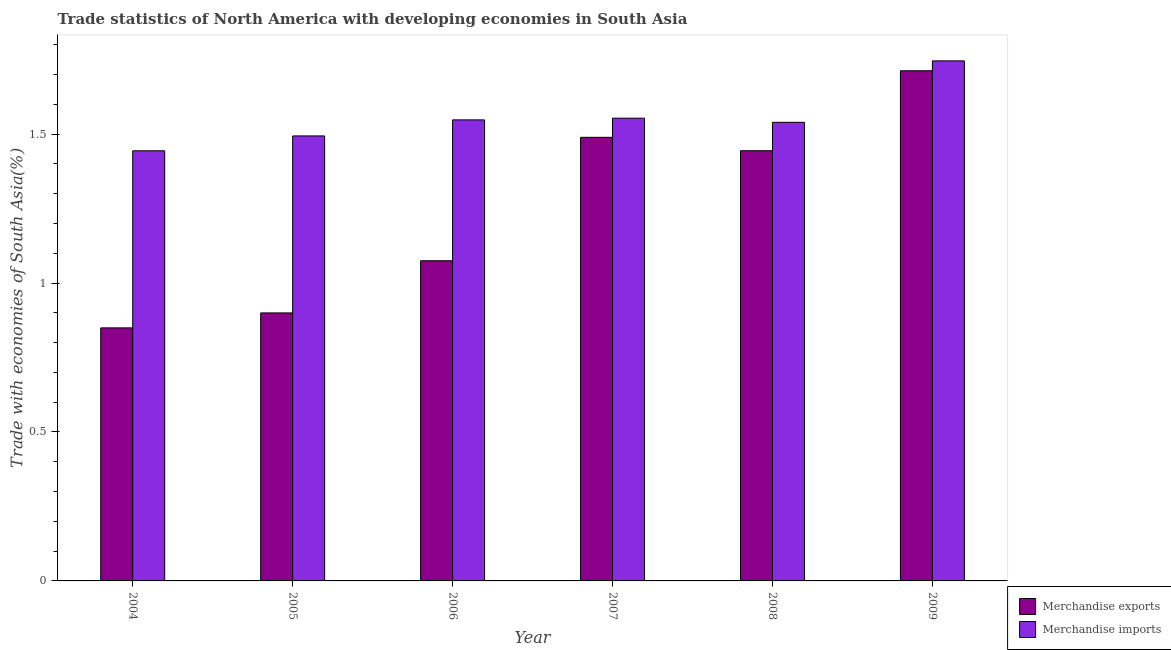How many different coloured bars are there?
Keep it short and to the point. 2. How many groups of bars are there?
Provide a short and direct response. 6. Are the number of bars on each tick of the X-axis equal?
Your response must be concise. Yes. How many bars are there on the 6th tick from the left?
Keep it short and to the point. 2. In how many cases, is the number of bars for a given year not equal to the number of legend labels?
Offer a very short reply. 0. What is the merchandise imports in 2004?
Provide a succinct answer. 1.44. Across all years, what is the maximum merchandise imports?
Make the answer very short. 1.75. Across all years, what is the minimum merchandise exports?
Give a very brief answer. 0.85. In which year was the merchandise exports minimum?
Provide a short and direct response. 2004. What is the total merchandise exports in the graph?
Provide a succinct answer. 7.47. What is the difference between the merchandise imports in 2004 and that in 2007?
Ensure brevity in your answer.  -0.11. What is the difference between the merchandise imports in 2008 and the merchandise exports in 2009?
Ensure brevity in your answer.  -0.21. What is the average merchandise exports per year?
Make the answer very short. 1.24. In the year 2009, what is the difference between the merchandise imports and merchandise exports?
Offer a terse response. 0. In how many years, is the merchandise imports greater than 1.2 %?
Provide a short and direct response. 6. What is the ratio of the merchandise imports in 2007 to that in 2009?
Keep it short and to the point. 0.89. Is the merchandise imports in 2005 less than that in 2008?
Keep it short and to the point. Yes. What is the difference between the highest and the second highest merchandise exports?
Make the answer very short. 0.22. What is the difference between the highest and the lowest merchandise imports?
Offer a terse response. 0.3. Is the sum of the merchandise imports in 2007 and 2008 greater than the maximum merchandise exports across all years?
Provide a short and direct response. Yes. How many bars are there?
Your answer should be very brief. 12. How many years are there in the graph?
Make the answer very short. 6. What is the difference between two consecutive major ticks on the Y-axis?
Make the answer very short. 0.5. Are the values on the major ticks of Y-axis written in scientific E-notation?
Your answer should be very brief. No. Does the graph contain grids?
Give a very brief answer. No. How many legend labels are there?
Keep it short and to the point. 2. How are the legend labels stacked?
Offer a terse response. Vertical. What is the title of the graph?
Provide a short and direct response. Trade statistics of North America with developing economies in South Asia. What is the label or title of the Y-axis?
Provide a short and direct response. Trade with economies of South Asia(%). What is the Trade with economies of South Asia(%) in Merchandise exports in 2004?
Provide a succinct answer. 0.85. What is the Trade with economies of South Asia(%) of Merchandise imports in 2004?
Ensure brevity in your answer.  1.44. What is the Trade with economies of South Asia(%) in Merchandise exports in 2005?
Ensure brevity in your answer.  0.9. What is the Trade with economies of South Asia(%) of Merchandise imports in 2005?
Your answer should be compact. 1.49. What is the Trade with economies of South Asia(%) of Merchandise exports in 2006?
Offer a terse response. 1.07. What is the Trade with economies of South Asia(%) of Merchandise imports in 2006?
Ensure brevity in your answer.  1.55. What is the Trade with economies of South Asia(%) in Merchandise exports in 2007?
Give a very brief answer. 1.49. What is the Trade with economies of South Asia(%) in Merchandise imports in 2007?
Your response must be concise. 1.55. What is the Trade with economies of South Asia(%) in Merchandise exports in 2008?
Make the answer very short. 1.44. What is the Trade with economies of South Asia(%) of Merchandise imports in 2008?
Your answer should be very brief. 1.54. What is the Trade with economies of South Asia(%) of Merchandise exports in 2009?
Ensure brevity in your answer.  1.71. What is the Trade with economies of South Asia(%) in Merchandise imports in 2009?
Make the answer very short. 1.75. Across all years, what is the maximum Trade with economies of South Asia(%) of Merchandise exports?
Give a very brief answer. 1.71. Across all years, what is the maximum Trade with economies of South Asia(%) in Merchandise imports?
Your response must be concise. 1.75. Across all years, what is the minimum Trade with economies of South Asia(%) of Merchandise exports?
Make the answer very short. 0.85. Across all years, what is the minimum Trade with economies of South Asia(%) in Merchandise imports?
Ensure brevity in your answer.  1.44. What is the total Trade with economies of South Asia(%) of Merchandise exports in the graph?
Your answer should be very brief. 7.47. What is the total Trade with economies of South Asia(%) in Merchandise imports in the graph?
Your response must be concise. 9.32. What is the difference between the Trade with economies of South Asia(%) in Merchandise exports in 2004 and that in 2005?
Keep it short and to the point. -0.05. What is the difference between the Trade with economies of South Asia(%) in Merchandise imports in 2004 and that in 2005?
Offer a terse response. -0.05. What is the difference between the Trade with economies of South Asia(%) of Merchandise exports in 2004 and that in 2006?
Make the answer very short. -0.23. What is the difference between the Trade with economies of South Asia(%) of Merchandise imports in 2004 and that in 2006?
Ensure brevity in your answer.  -0.1. What is the difference between the Trade with economies of South Asia(%) in Merchandise exports in 2004 and that in 2007?
Your answer should be very brief. -0.64. What is the difference between the Trade with economies of South Asia(%) of Merchandise imports in 2004 and that in 2007?
Your answer should be compact. -0.11. What is the difference between the Trade with economies of South Asia(%) of Merchandise exports in 2004 and that in 2008?
Your response must be concise. -0.59. What is the difference between the Trade with economies of South Asia(%) of Merchandise imports in 2004 and that in 2008?
Your answer should be very brief. -0.1. What is the difference between the Trade with economies of South Asia(%) in Merchandise exports in 2004 and that in 2009?
Provide a short and direct response. -0.86. What is the difference between the Trade with economies of South Asia(%) of Merchandise imports in 2004 and that in 2009?
Give a very brief answer. -0.3. What is the difference between the Trade with economies of South Asia(%) of Merchandise exports in 2005 and that in 2006?
Your response must be concise. -0.18. What is the difference between the Trade with economies of South Asia(%) of Merchandise imports in 2005 and that in 2006?
Keep it short and to the point. -0.05. What is the difference between the Trade with economies of South Asia(%) of Merchandise exports in 2005 and that in 2007?
Your answer should be compact. -0.59. What is the difference between the Trade with economies of South Asia(%) of Merchandise imports in 2005 and that in 2007?
Your response must be concise. -0.06. What is the difference between the Trade with economies of South Asia(%) of Merchandise exports in 2005 and that in 2008?
Keep it short and to the point. -0.54. What is the difference between the Trade with economies of South Asia(%) in Merchandise imports in 2005 and that in 2008?
Your response must be concise. -0.05. What is the difference between the Trade with economies of South Asia(%) of Merchandise exports in 2005 and that in 2009?
Provide a short and direct response. -0.81. What is the difference between the Trade with economies of South Asia(%) of Merchandise imports in 2005 and that in 2009?
Ensure brevity in your answer.  -0.25. What is the difference between the Trade with economies of South Asia(%) of Merchandise exports in 2006 and that in 2007?
Provide a succinct answer. -0.41. What is the difference between the Trade with economies of South Asia(%) in Merchandise imports in 2006 and that in 2007?
Offer a terse response. -0.01. What is the difference between the Trade with economies of South Asia(%) of Merchandise exports in 2006 and that in 2008?
Your answer should be compact. -0.37. What is the difference between the Trade with economies of South Asia(%) in Merchandise imports in 2006 and that in 2008?
Provide a succinct answer. 0.01. What is the difference between the Trade with economies of South Asia(%) of Merchandise exports in 2006 and that in 2009?
Your answer should be very brief. -0.64. What is the difference between the Trade with economies of South Asia(%) in Merchandise imports in 2006 and that in 2009?
Your answer should be very brief. -0.2. What is the difference between the Trade with economies of South Asia(%) in Merchandise exports in 2007 and that in 2008?
Give a very brief answer. 0.04. What is the difference between the Trade with economies of South Asia(%) of Merchandise imports in 2007 and that in 2008?
Ensure brevity in your answer.  0.01. What is the difference between the Trade with economies of South Asia(%) of Merchandise exports in 2007 and that in 2009?
Give a very brief answer. -0.22. What is the difference between the Trade with economies of South Asia(%) in Merchandise imports in 2007 and that in 2009?
Your response must be concise. -0.19. What is the difference between the Trade with economies of South Asia(%) of Merchandise exports in 2008 and that in 2009?
Your answer should be compact. -0.27. What is the difference between the Trade with economies of South Asia(%) of Merchandise imports in 2008 and that in 2009?
Keep it short and to the point. -0.21. What is the difference between the Trade with economies of South Asia(%) in Merchandise exports in 2004 and the Trade with economies of South Asia(%) in Merchandise imports in 2005?
Ensure brevity in your answer.  -0.64. What is the difference between the Trade with economies of South Asia(%) in Merchandise exports in 2004 and the Trade with economies of South Asia(%) in Merchandise imports in 2006?
Provide a short and direct response. -0.7. What is the difference between the Trade with economies of South Asia(%) in Merchandise exports in 2004 and the Trade with economies of South Asia(%) in Merchandise imports in 2007?
Provide a short and direct response. -0.7. What is the difference between the Trade with economies of South Asia(%) of Merchandise exports in 2004 and the Trade with economies of South Asia(%) of Merchandise imports in 2008?
Ensure brevity in your answer.  -0.69. What is the difference between the Trade with economies of South Asia(%) of Merchandise exports in 2004 and the Trade with economies of South Asia(%) of Merchandise imports in 2009?
Provide a short and direct response. -0.9. What is the difference between the Trade with economies of South Asia(%) of Merchandise exports in 2005 and the Trade with economies of South Asia(%) of Merchandise imports in 2006?
Offer a terse response. -0.65. What is the difference between the Trade with economies of South Asia(%) of Merchandise exports in 2005 and the Trade with economies of South Asia(%) of Merchandise imports in 2007?
Keep it short and to the point. -0.65. What is the difference between the Trade with economies of South Asia(%) of Merchandise exports in 2005 and the Trade with economies of South Asia(%) of Merchandise imports in 2008?
Your answer should be compact. -0.64. What is the difference between the Trade with economies of South Asia(%) of Merchandise exports in 2005 and the Trade with economies of South Asia(%) of Merchandise imports in 2009?
Your answer should be compact. -0.85. What is the difference between the Trade with economies of South Asia(%) of Merchandise exports in 2006 and the Trade with economies of South Asia(%) of Merchandise imports in 2007?
Ensure brevity in your answer.  -0.48. What is the difference between the Trade with economies of South Asia(%) in Merchandise exports in 2006 and the Trade with economies of South Asia(%) in Merchandise imports in 2008?
Give a very brief answer. -0.46. What is the difference between the Trade with economies of South Asia(%) of Merchandise exports in 2006 and the Trade with economies of South Asia(%) of Merchandise imports in 2009?
Offer a terse response. -0.67. What is the difference between the Trade with economies of South Asia(%) in Merchandise exports in 2007 and the Trade with economies of South Asia(%) in Merchandise imports in 2008?
Your response must be concise. -0.05. What is the difference between the Trade with economies of South Asia(%) of Merchandise exports in 2007 and the Trade with economies of South Asia(%) of Merchandise imports in 2009?
Provide a short and direct response. -0.26. What is the difference between the Trade with economies of South Asia(%) in Merchandise exports in 2008 and the Trade with economies of South Asia(%) in Merchandise imports in 2009?
Provide a succinct answer. -0.3. What is the average Trade with economies of South Asia(%) of Merchandise exports per year?
Your response must be concise. 1.25. What is the average Trade with economies of South Asia(%) in Merchandise imports per year?
Make the answer very short. 1.55. In the year 2004, what is the difference between the Trade with economies of South Asia(%) of Merchandise exports and Trade with economies of South Asia(%) of Merchandise imports?
Keep it short and to the point. -0.59. In the year 2005, what is the difference between the Trade with economies of South Asia(%) in Merchandise exports and Trade with economies of South Asia(%) in Merchandise imports?
Give a very brief answer. -0.59. In the year 2006, what is the difference between the Trade with economies of South Asia(%) of Merchandise exports and Trade with economies of South Asia(%) of Merchandise imports?
Offer a very short reply. -0.47. In the year 2007, what is the difference between the Trade with economies of South Asia(%) in Merchandise exports and Trade with economies of South Asia(%) in Merchandise imports?
Your response must be concise. -0.06. In the year 2008, what is the difference between the Trade with economies of South Asia(%) in Merchandise exports and Trade with economies of South Asia(%) in Merchandise imports?
Give a very brief answer. -0.1. In the year 2009, what is the difference between the Trade with economies of South Asia(%) of Merchandise exports and Trade with economies of South Asia(%) of Merchandise imports?
Your response must be concise. -0.03. What is the ratio of the Trade with economies of South Asia(%) of Merchandise exports in 2004 to that in 2005?
Give a very brief answer. 0.94. What is the ratio of the Trade with economies of South Asia(%) of Merchandise imports in 2004 to that in 2005?
Offer a terse response. 0.97. What is the ratio of the Trade with economies of South Asia(%) in Merchandise exports in 2004 to that in 2006?
Your response must be concise. 0.79. What is the ratio of the Trade with economies of South Asia(%) of Merchandise imports in 2004 to that in 2006?
Offer a very short reply. 0.93. What is the ratio of the Trade with economies of South Asia(%) of Merchandise exports in 2004 to that in 2007?
Your answer should be very brief. 0.57. What is the ratio of the Trade with economies of South Asia(%) of Merchandise imports in 2004 to that in 2007?
Ensure brevity in your answer.  0.93. What is the ratio of the Trade with economies of South Asia(%) in Merchandise exports in 2004 to that in 2008?
Provide a succinct answer. 0.59. What is the ratio of the Trade with economies of South Asia(%) of Merchandise imports in 2004 to that in 2008?
Your answer should be compact. 0.94. What is the ratio of the Trade with economies of South Asia(%) of Merchandise exports in 2004 to that in 2009?
Ensure brevity in your answer.  0.5. What is the ratio of the Trade with economies of South Asia(%) of Merchandise imports in 2004 to that in 2009?
Your answer should be very brief. 0.83. What is the ratio of the Trade with economies of South Asia(%) of Merchandise exports in 2005 to that in 2006?
Your response must be concise. 0.84. What is the ratio of the Trade with economies of South Asia(%) in Merchandise imports in 2005 to that in 2006?
Offer a terse response. 0.97. What is the ratio of the Trade with economies of South Asia(%) of Merchandise exports in 2005 to that in 2007?
Your response must be concise. 0.6. What is the ratio of the Trade with economies of South Asia(%) of Merchandise imports in 2005 to that in 2007?
Provide a short and direct response. 0.96. What is the ratio of the Trade with economies of South Asia(%) in Merchandise exports in 2005 to that in 2008?
Offer a terse response. 0.62. What is the ratio of the Trade with economies of South Asia(%) of Merchandise imports in 2005 to that in 2008?
Offer a very short reply. 0.97. What is the ratio of the Trade with economies of South Asia(%) of Merchandise exports in 2005 to that in 2009?
Ensure brevity in your answer.  0.53. What is the ratio of the Trade with economies of South Asia(%) in Merchandise imports in 2005 to that in 2009?
Offer a very short reply. 0.86. What is the ratio of the Trade with economies of South Asia(%) of Merchandise exports in 2006 to that in 2007?
Give a very brief answer. 0.72. What is the ratio of the Trade with economies of South Asia(%) of Merchandise exports in 2006 to that in 2008?
Ensure brevity in your answer.  0.74. What is the ratio of the Trade with economies of South Asia(%) of Merchandise imports in 2006 to that in 2008?
Give a very brief answer. 1.01. What is the ratio of the Trade with economies of South Asia(%) of Merchandise exports in 2006 to that in 2009?
Offer a very short reply. 0.63. What is the ratio of the Trade with economies of South Asia(%) in Merchandise imports in 2006 to that in 2009?
Offer a very short reply. 0.89. What is the ratio of the Trade with economies of South Asia(%) in Merchandise exports in 2007 to that in 2008?
Offer a very short reply. 1.03. What is the ratio of the Trade with economies of South Asia(%) in Merchandise exports in 2007 to that in 2009?
Ensure brevity in your answer.  0.87. What is the ratio of the Trade with economies of South Asia(%) of Merchandise imports in 2007 to that in 2009?
Provide a succinct answer. 0.89. What is the ratio of the Trade with economies of South Asia(%) in Merchandise exports in 2008 to that in 2009?
Give a very brief answer. 0.84. What is the ratio of the Trade with economies of South Asia(%) in Merchandise imports in 2008 to that in 2009?
Your response must be concise. 0.88. What is the difference between the highest and the second highest Trade with economies of South Asia(%) in Merchandise exports?
Give a very brief answer. 0.22. What is the difference between the highest and the second highest Trade with economies of South Asia(%) of Merchandise imports?
Keep it short and to the point. 0.19. What is the difference between the highest and the lowest Trade with economies of South Asia(%) in Merchandise exports?
Make the answer very short. 0.86. What is the difference between the highest and the lowest Trade with economies of South Asia(%) in Merchandise imports?
Provide a short and direct response. 0.3. 